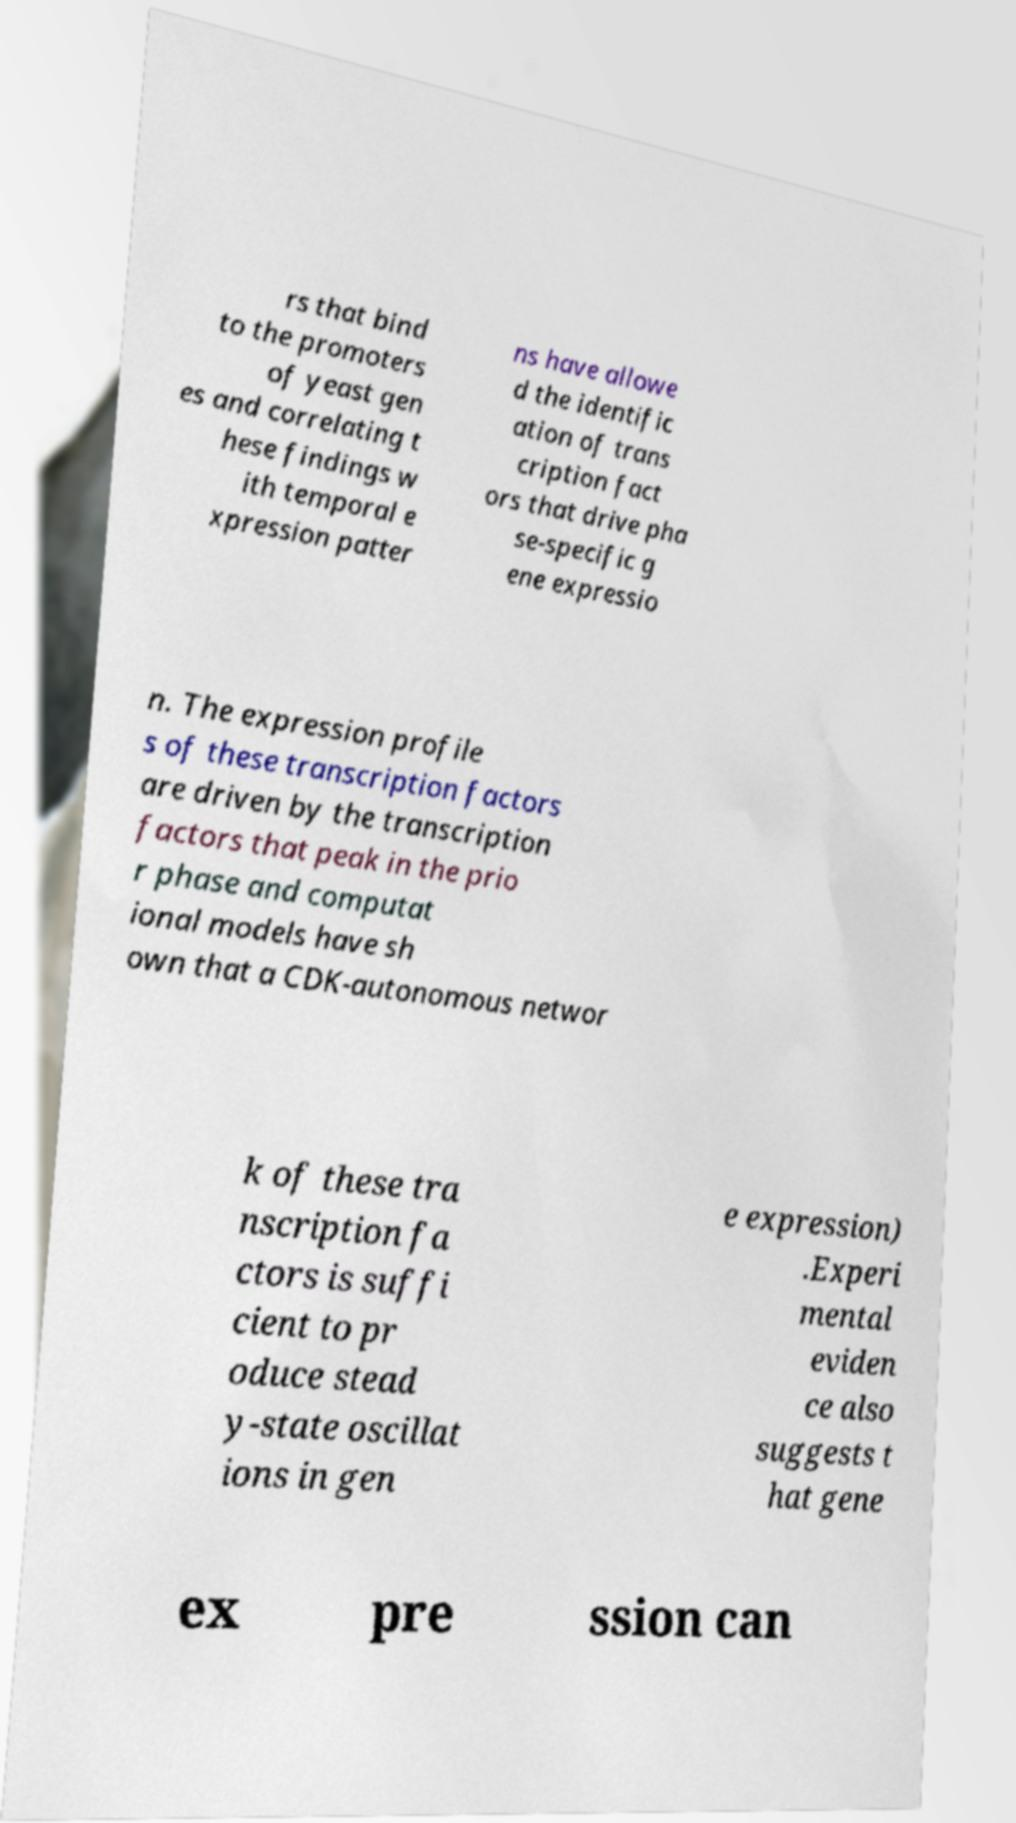Could you assist in decoding the text presented in this image and type it out clearly? rs that bind to the promoters of yeast gen es and correlating t hese findings w ith temporal e xpression patter ns have allowe d the identific ation of trans cription fact ors that drive pha se-specific g ene expressio n. The expression profile s of these transcription factors are driven by the transcription factors that peak in the prio r phase and computat ional models have sh own that a CDK-autonomous networ k of these tra nscription fa ctors is suffi cient to pr oduce stead y-state oscillat ions in gen e expression) .Experi mental eviden ce also suggests t hat gene ex pre ssion can 